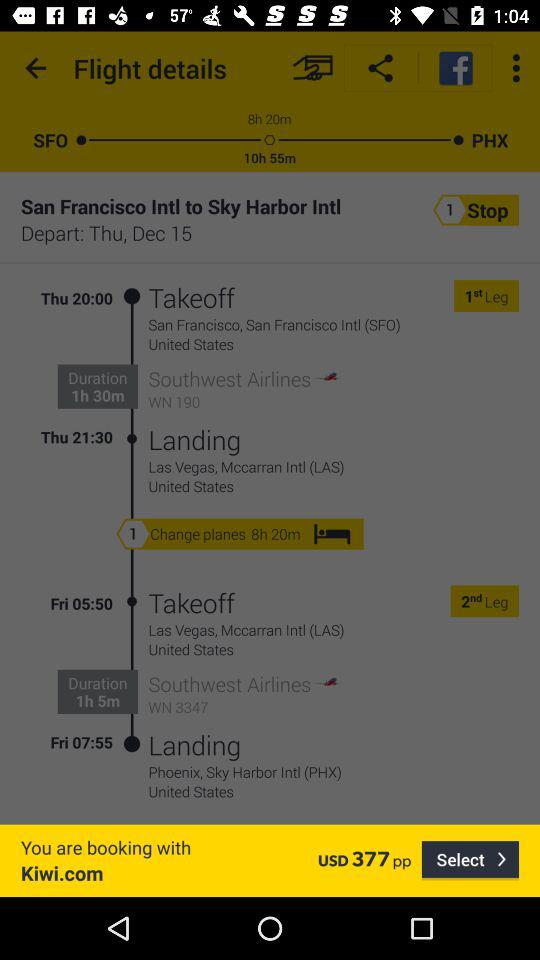How many hours is the total flight time?
Answer the question using a single word or phrase. 10h 55m 